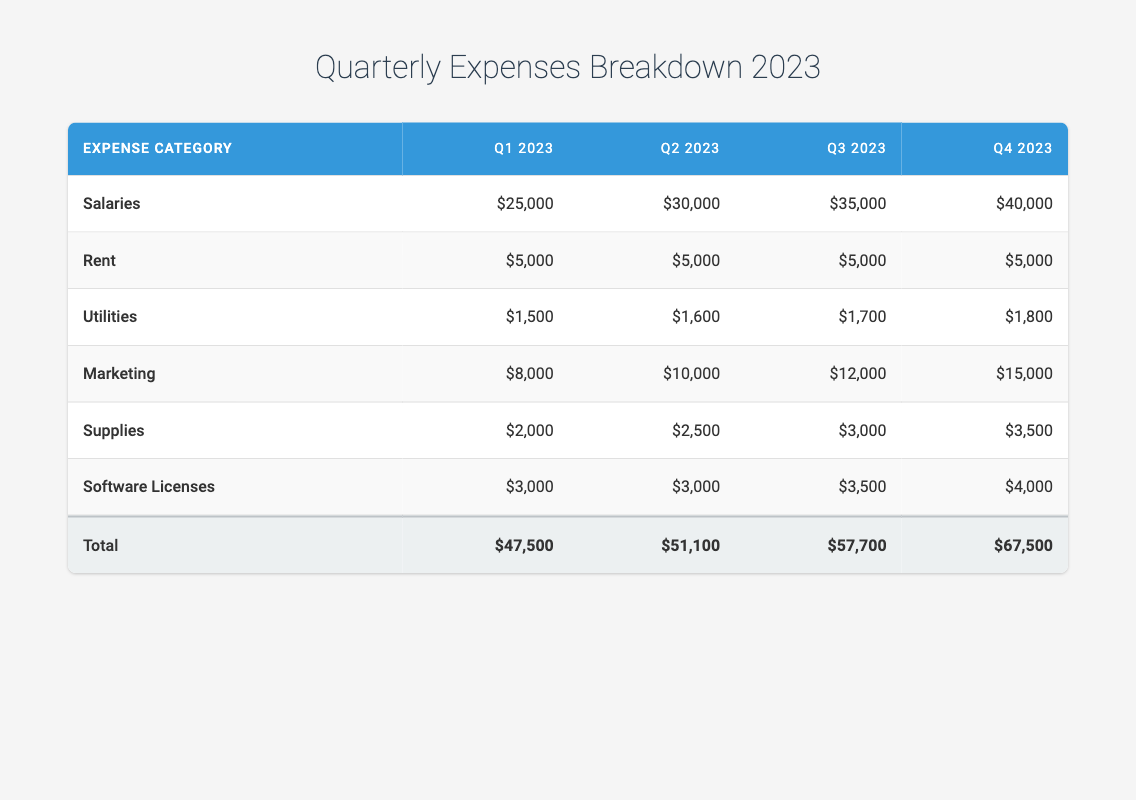What was the total expense in Q2 2023? The total expense for Q2 2023 is clearly indicated in the last row under the "Total" column, which shows $51,100.
Answer: 51,100 What is the difference in total expenses between Q3 2023 and Q1 2023? For Q3 2023, the total is $57,700 and for Q1 2023, the total is $47,500. To find the difference, subtract Q1 total from Q3 total: $57,700 - $47,500 = $10,200.
Answer: 10,200 Did the utility expenses increase from Q1 2023 to Q4 2023? The utility expenses for Q1 2023 are $1,500 and for Q4 2023, they are $1,800. Since $1,800 is greater than $1,500, the answer is yes.
Answer: Yes What is the average salary expense per quarter for 2023? The salary expenses for each quarter are $25,000, $30,000, $35,000, and $40,000. To find the average, sum these amounts: $25,000 + $30,000 + $35,000 + $40,000 = $130,000. Then divide by 4 quarters: $130,000 / 4 = $32,500.
Answer: 32,500 What was the highest marketing expense in any quarter? By inspecting the marketing expenses in each quarter, $15,000 in Q4 2023 is the highest amount, compared to $8,000, $10,000, and $12,000 in the previous quarters.
Answer: 15,000 How much did the supplies expense increase from Q2 2023 to Q3 2023? The supplies expense for Q2 2023 is $2,500 and for Q3 2023, it is $3,000. To calculate the increase, subtract Q2 supplies from Q3 supplies: $3,000 - $2,500 = $500.
Answer: 500 Was the total expense in Q4 2023 more than the total of Q1 and Q2 combined? The total expense for Q4 2023 is $67,500. The combined total for Q1 and Q2 is $47,500 + $51,100 = $98,600. Since $67,500 is less than $98,600, the answer is no.
Answer: No What was the total expense for the first half of 2023? To find the total expense for the first half, sum the totals of Q1 and Q2: $47,500 + $51,100 = $98,600.
Answer: 98,600 